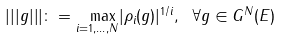Convert formula to latex. <formula><loc_0><loc_0><loc_500><loc_500>| | | g | | | \colon = \underset { i = 1 , \dots , N } { \ \max } | \rho _ { i } ( g ) | ^ { 1 / i } , \text {  } \forall g \in G ^ { N } ( E )</formula> 